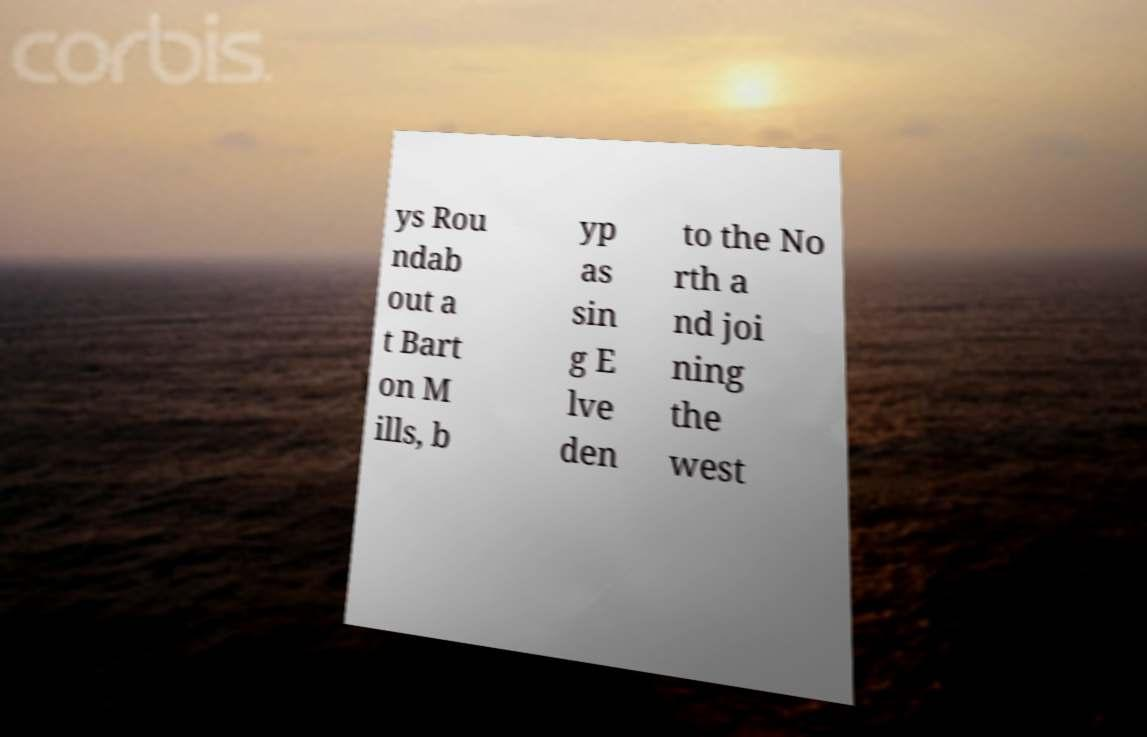Could you assist in decoding the text presented in this image and type it out clearly? ys Rou ndab out a t Bart on M ills, b yp as sin g E lve den to the No rth a nd joi ning the west 